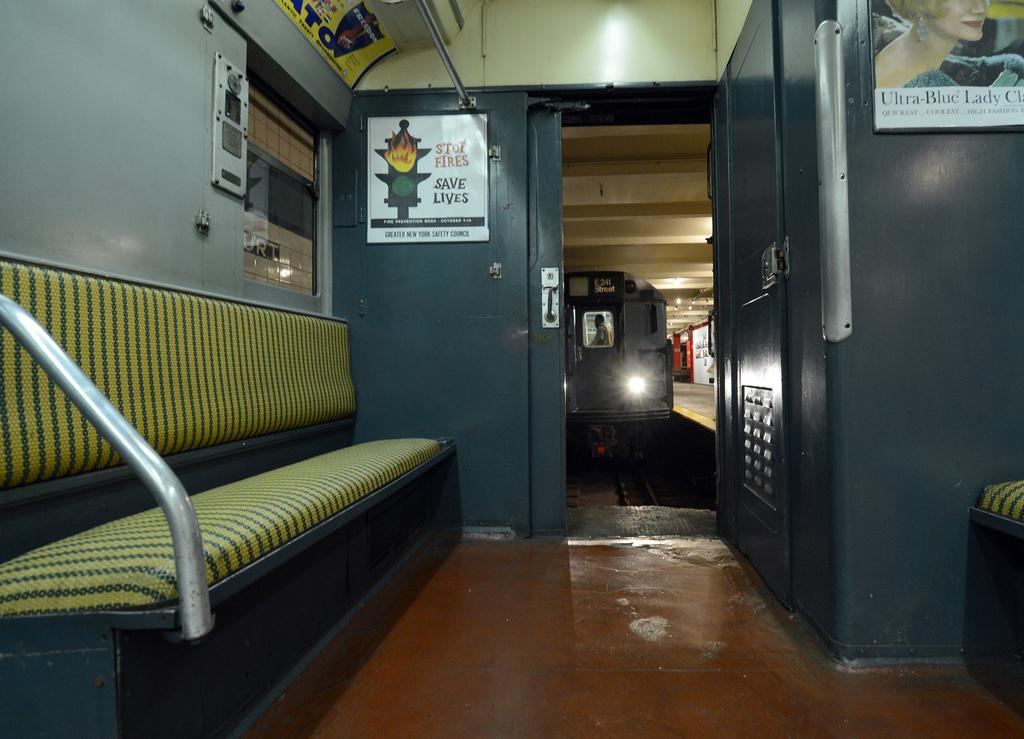<image>
Present a compact description of the photo's key features. an inside of a train with a sign saying ST of Fire Saves Lives. 